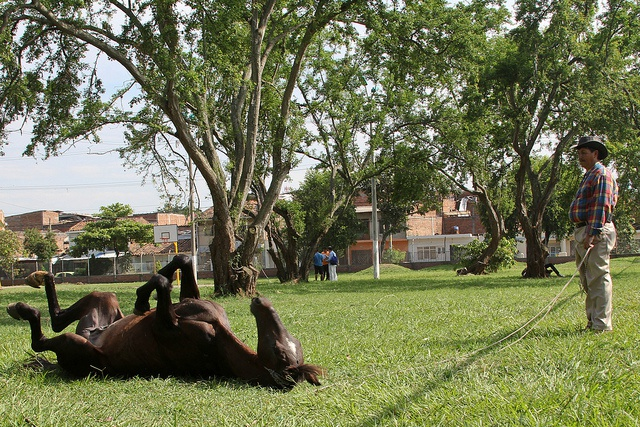Describe the objects in this image and their specific colors. I can see horse in green, black, maroon, and gray tones, people in green, black, gray, darkgreen, and maroon tones, people in green, darkgray, black, gray, and navy tones, people in green, black, blue, and navy tones, and people in green, black, maroon, olive, and gray tones in this image. 